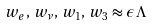<formula> <loc_0><loc_0><loc_500><loc_500>w _ { e } , \, w _ { \nu } , \, w _ { 1 } , \, w _ { 3 } \approx \epsilon \, \Lambda</formula> 